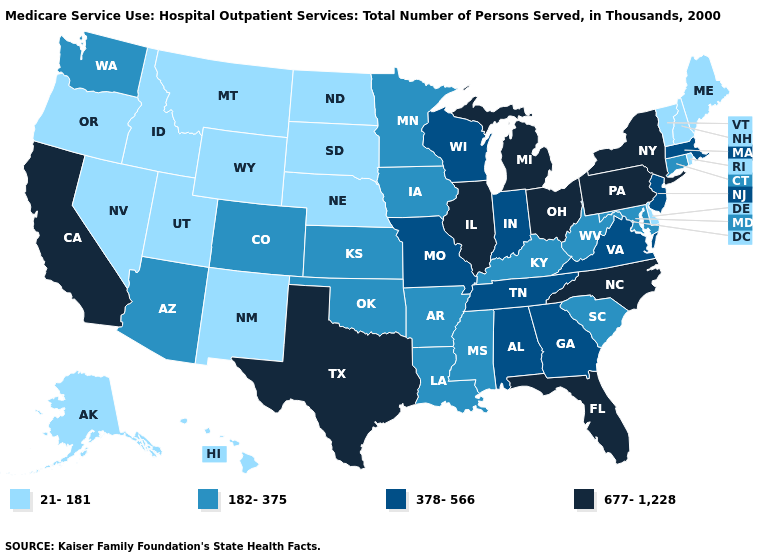Which states have the highest value in the USA?
Concise answer only. California, Florida, Illinois, Michigan, New York, North Carolina, Ohio, Pennsylvania, Texas. Which states have the highest value in the USA?
Be succinct. California, Florida, Illinois, Michigan, New York, North Carolina, Ohio, Pennsylvania, Texas. Does Florida have the same value as Pennsylvania?
Concise answer only. Yes. What is the value of North Dakota?
Quick response, please. 21-181. What is the value of Georgia?
Quick response, please. 378-566. Does Nevada have the highest value in the West?
Be succinct. No. Does the map have missing data?
Be succinct. No. What is the value of Illinois?
Concise answer only. 677-1,228. Name the states that have a value in the range 677-1,228?
Short answer required. California, Florida, Illinois, Michigan, New York, North Carolina, Ohio, Pennsylvania, Texas. What is the value of Missouri?
Write a very short answer. 378-566. Does the map have missing data?
Be succinct. No. Among the states that border Kansas , which have the lowest value?
Answer briefly. Nebraska. Does Hawaii have a lower value than Oregon?
Answer briefly. No. Does Alabama have the same value as Texas?
Quick response, please. No. Among the states that border Utah , which have the lowest value?
Keep it brief. Idaho, Nevada, New Mexico, Wyoming. 